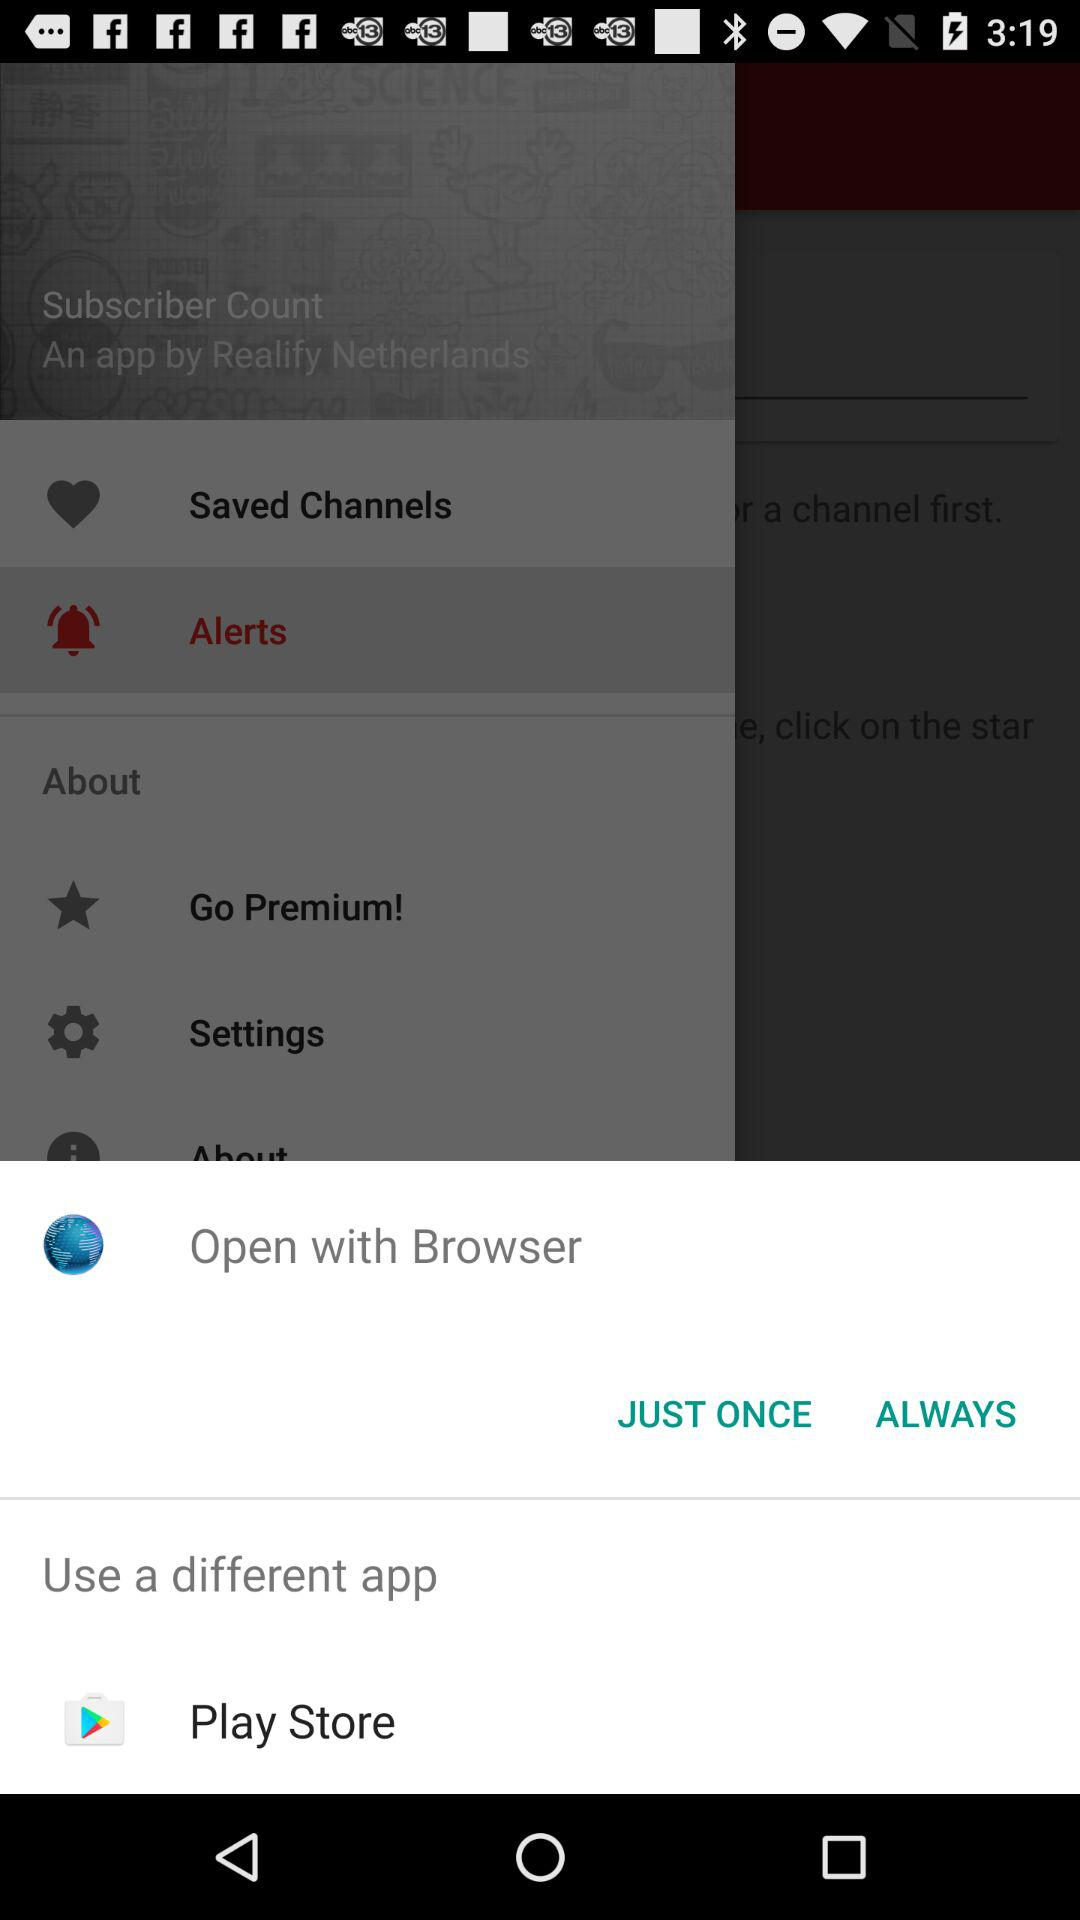Through which application can we open it? You can open it through "Browser" and "Play Store". 